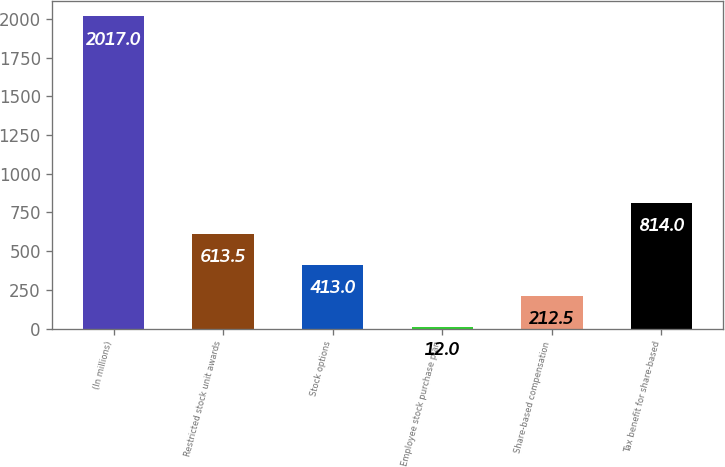<chart> <loc_0><loc_0><loc_500><loc_500><bar_chart><fcel>(In millions)<fcel>Restricted stock unit awards<fcel>Stock options<fcel>Employee stock purchase plan<fcel>Share-based compensation<fcel>Tax benefit for share-based<nl><fcel>2017<fcel>613.5<fcel>413<fcel>12<fcel>212.5<fcel>814<nl></chart> 